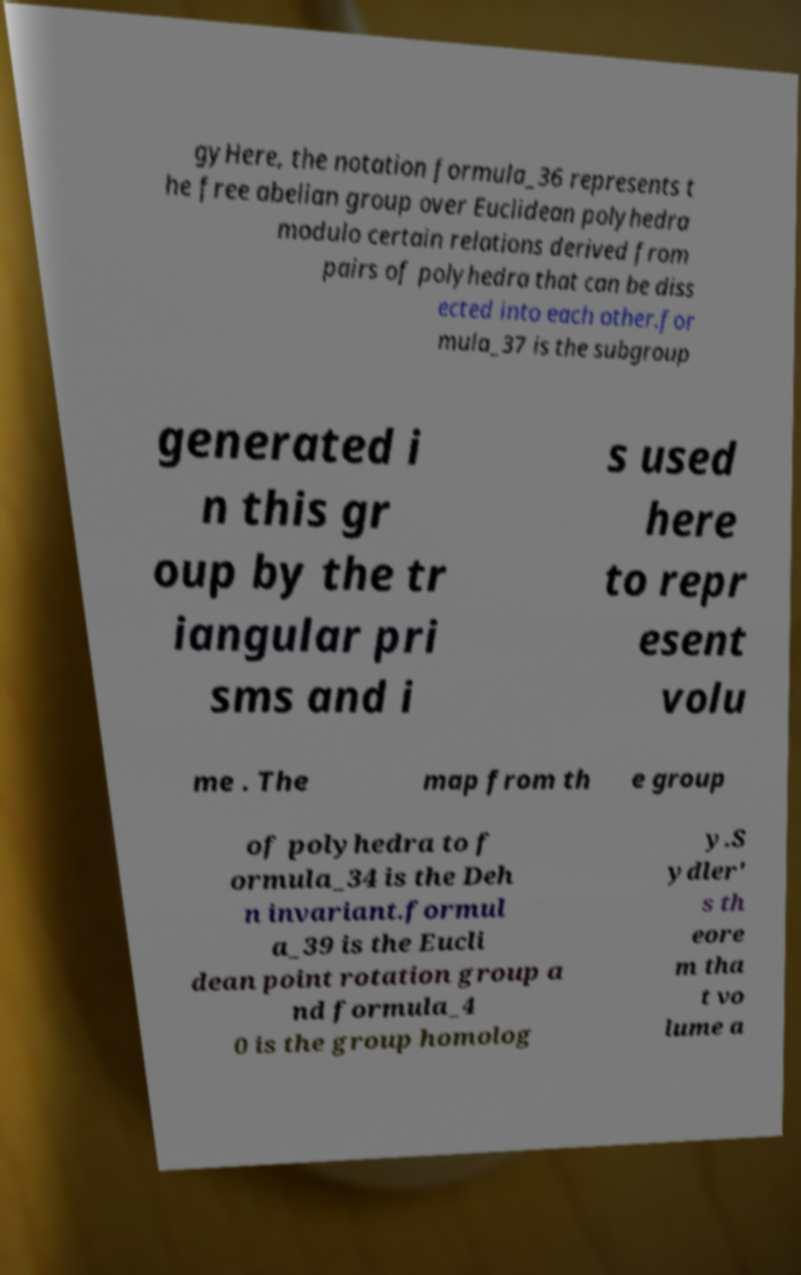What messages or text are displayed in this image? I need them in a readable, typed format. gyHere, the notation formula_36 represents t he free abelian group over Euclidean polyhedra modulo certain relations derived from pairs of polyhedra that can be diss ected into each other.for mula_37 is the subgroup generated i n this gr oup by the tr iangular pri sms and i s used here to repr esent volu me . The map from th e group of polyhedra to f ormula_34 is the Deh n invariant.formul a_39 is the Eucli dean point rotation group a nd formula_4 0 is the group homolog y.S ydler' s th eore m tha t vo lume a 